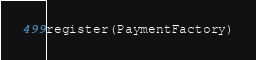<code> <loc_0><loc_0><loc_500><loc_500><_Python_>register(PaymentFactory)
</code> 